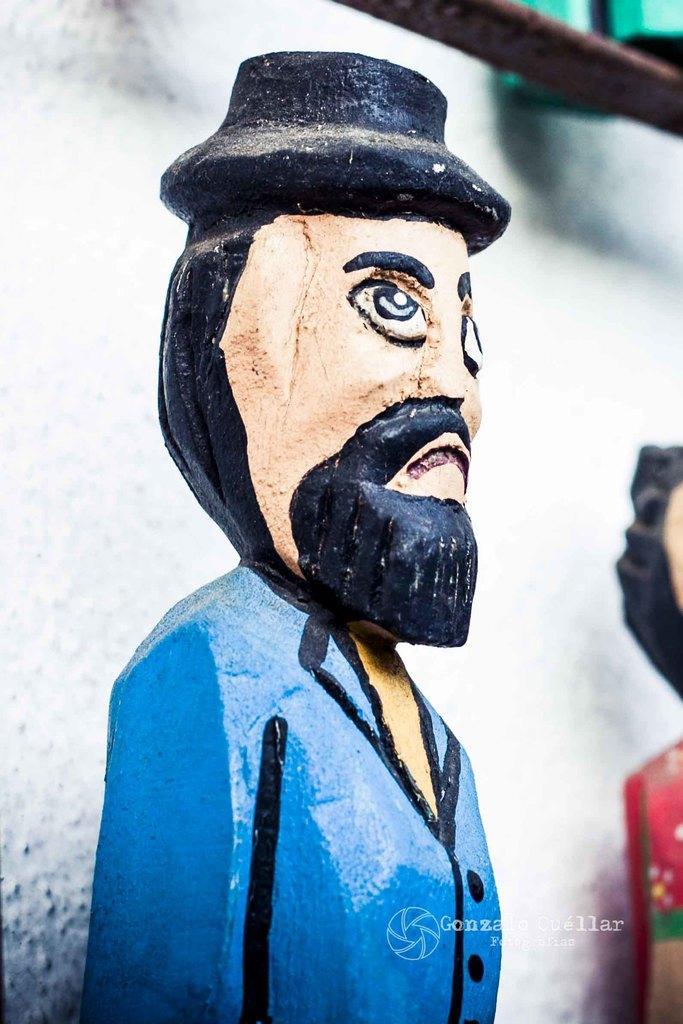How would you summarize this image in a sentence or two? In this picture there is a statue of a person. On the right there is another statue. The background is a white wall. At the top there is a iron bar. 